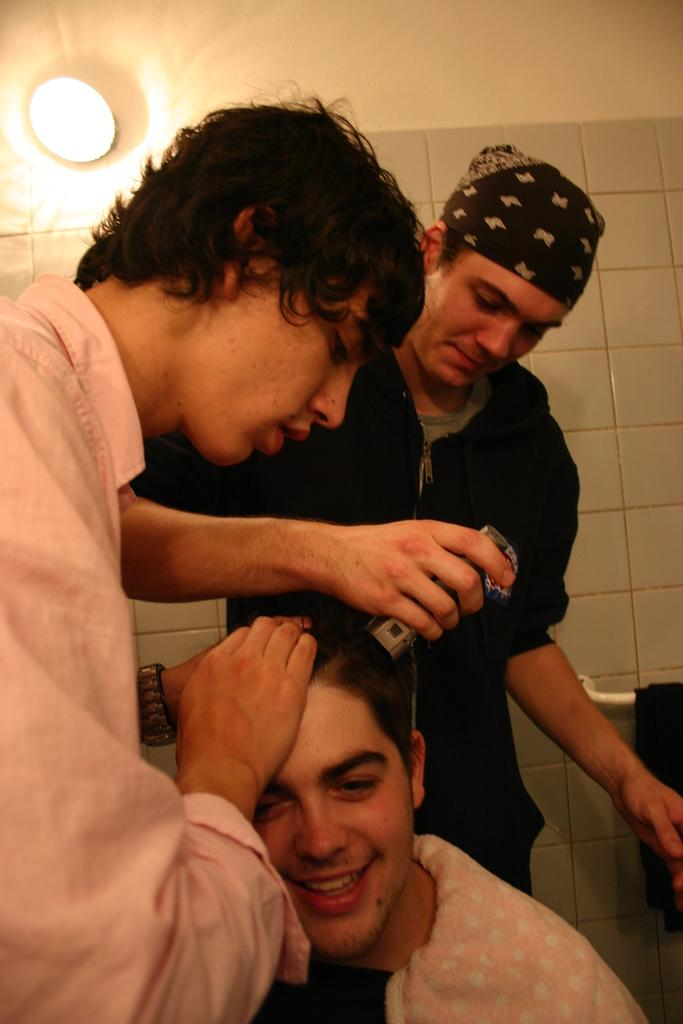How many people are in the image? There are two persons in the image. What is one person doing in the image? One person is holding an object. Can you describe the lighting in the image? There is a light visible at the bottom of the image. What is visible at the top of the image? A wall is visible at the top of the image. What type of steam is coming from the cook's pot in the image? There is no cook or pot present in the image, so there is no steam to describe. 